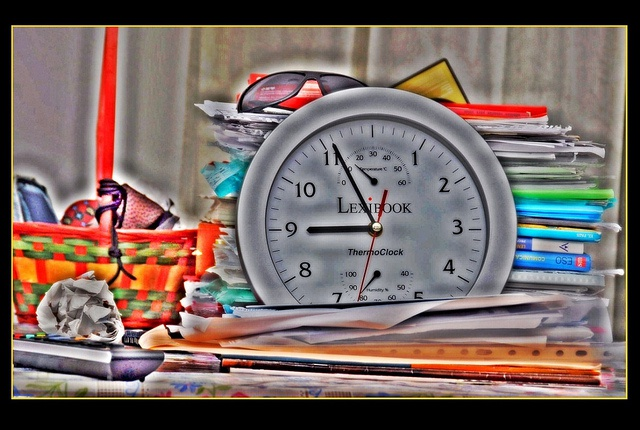Describe the objects in this image and their specific colors. I can see clock in black, darkgray, and gray tones, remote in black, gray, lightgray, and darkgray tones, book in black, maroon, and brown tones, book in black, green, lightgreen, and teal tones, and book in black, red, and salmon tones in this image. 